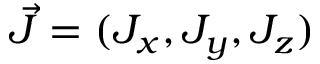<formula> <loc_0><loc_0><loc_500><loc_500>\vec { J } = ( J _ { x } , J _ { y } , J _ { z } )</formula> 